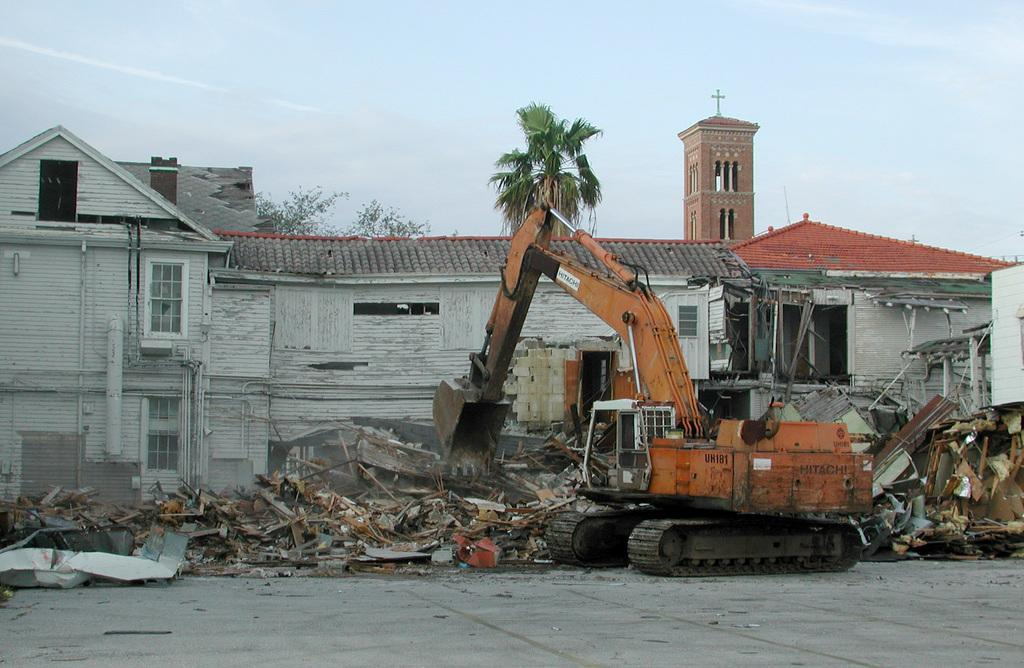What type of structure is visible in the image? There is a house in the image. What is happening to the house? The house is being deconstructed by a crane. What can be seen behind the house? There is a tree and a church behind the house. Where is the farmer standing with the hose in the image? There is no farmer or hose present in the image. 